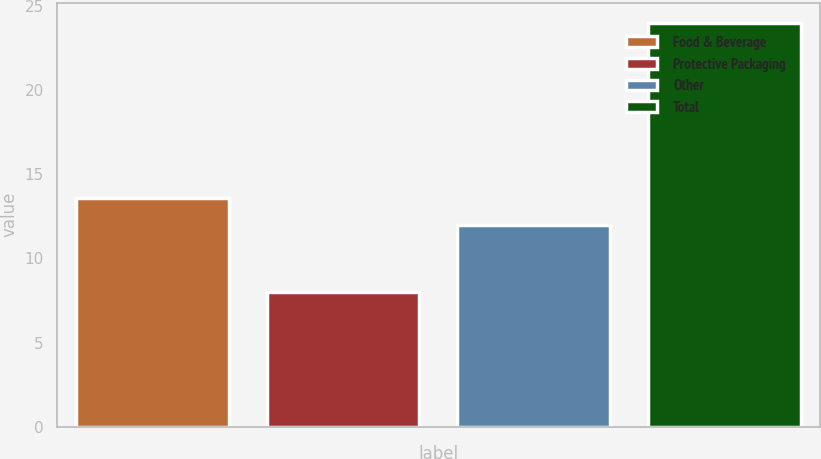Convert chart. <chart><loc_0><loc_0><loc_500><loc_500><bar_chart><fcel>Food & Beverage<fcel>Protective Packaging<fcel>Other<fcel>Total<nl><fcel>13.6<fcel>8<fcel>12<fcel>24<nl></chart> 